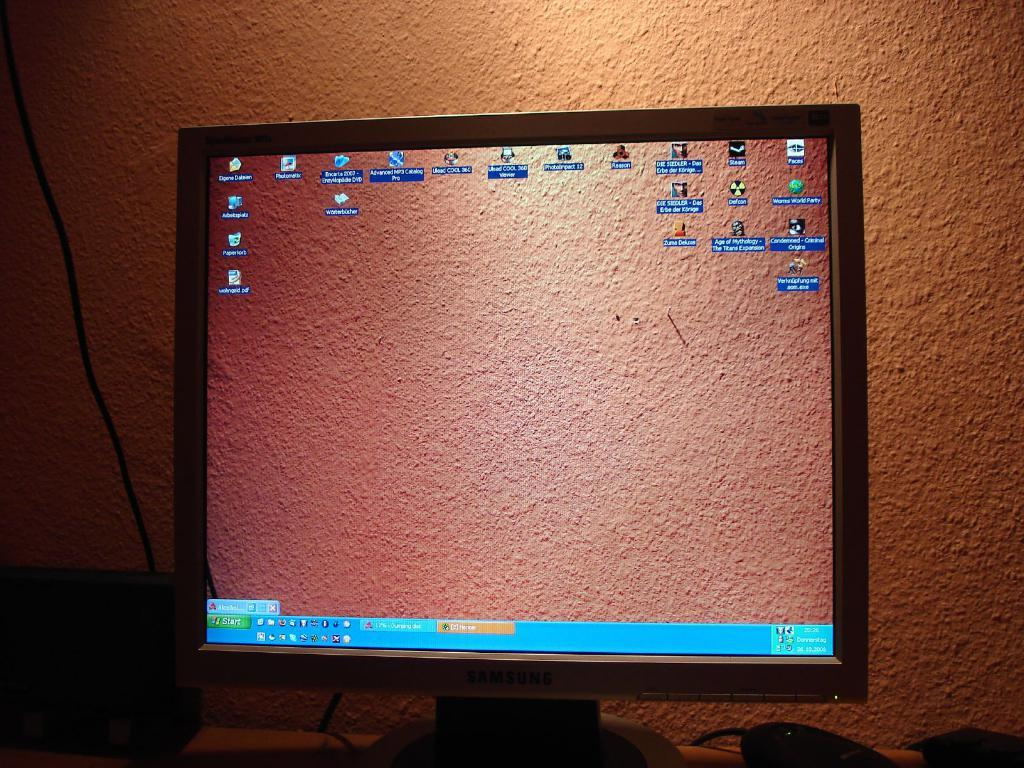<image>
Offer a succinct explanation of the picture presented. monitor has windows xp start button and that has wallpaper matching the real wall 